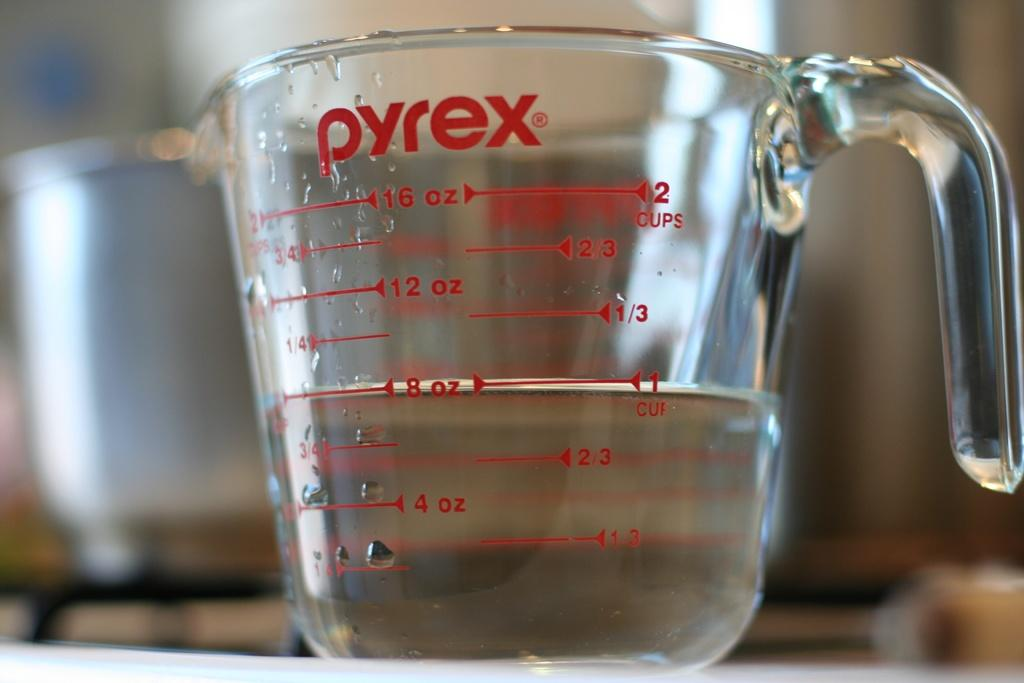<image>
Render a clear and concise summary of the photo. a clear Pyrex measuring cup with 8oz of liquid in it 